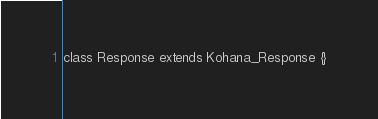Convert code to text. <code><loc_0><loc_0><loc_500><loc_500><_PHP_>class Response extends Kohana_Response {}</code> 